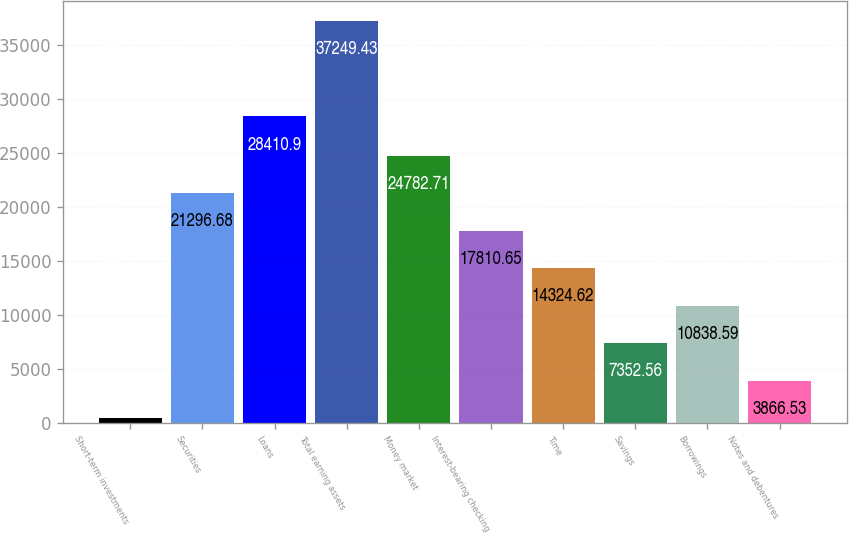Convert chart to OTSL. <chart><loc_0><loc_0><loc_500><loc_500><bar_chart><fcel>Short-term investments<fcel>Securities<fcel>Loans<fcel>Total earning assets<fcel>Money market<fcel>Interest-bearing checking<fcel>Time<fcel>Savings<fcel>Borrowings<fcel>Notes and debentures<nl><fcel>380.5<fcel>21296.7<fcel>28410.9<fcel>37249.4<fcel>24782.7<fcel>17810.7<fcel>14324.6<fcel>7352.56<fcel>10838.6<fcel>3866.53<nl></chart> 